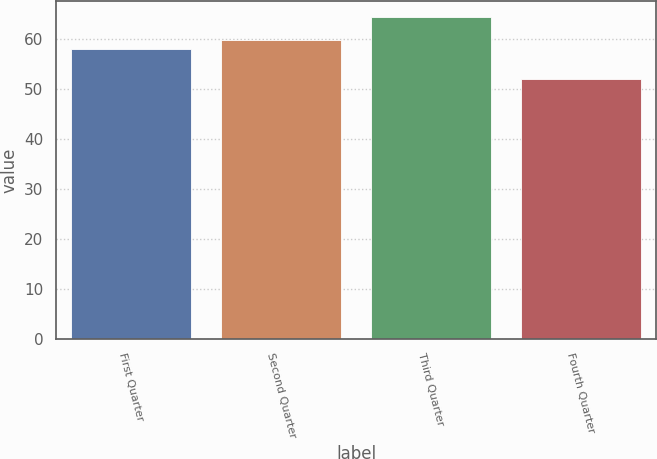<chart> <loc_0><loc_0><loc_500><loc_500><bar_chart><fcel>First Quarter<fcel>Second Quarter<fcel>Third Quarter<fcel>Fourth Quarter<nl><fcel>58<fcel>59.79<fcel>64.41<fcel>52.01<nl></chart> 